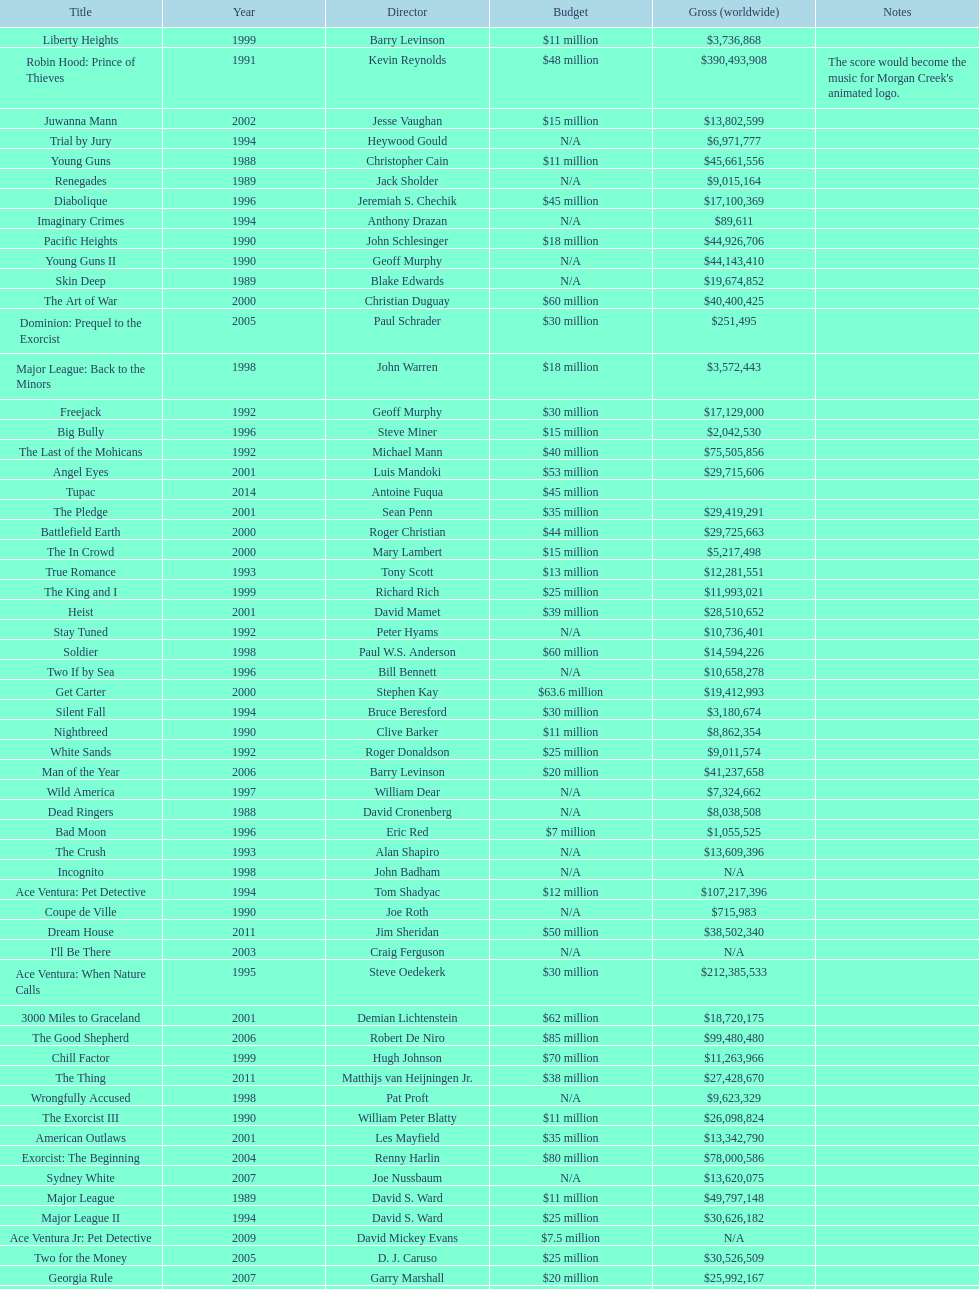Did true romance make more or less money than diabolique? Less. 